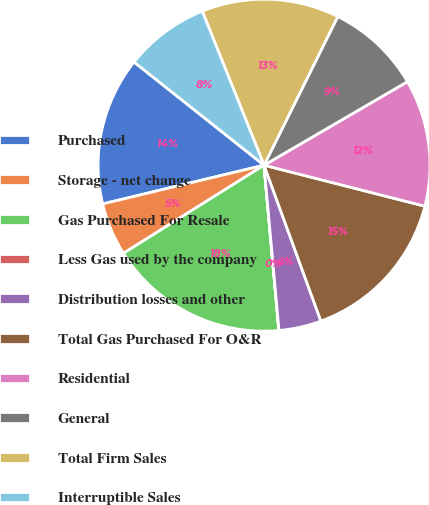Convert chart to OTSL. <chart><loc_0><loc_0><loc_500><loc_500><pie_chart><fcel>Purchased<fcel>Storage - net change<fcel>Gas Purchased For Resale<fcel>Less Gas used by the company<fcel>Distribution losses and other<fcel>Total Gas Purchased For O&R<fcel>Residential<fcel>General<fcel>Total Firm Sales<fcel>Interruptible Sales<nl><fcel>14.43%<fcel>5.16%<fcel>17.51%<fcel>0.02%<fcel>4.13%<fcel>15.46%<fcel>12.37%<fcel>9.28%<fcel>13.4%<fcel>8.25%<nl></chart> 